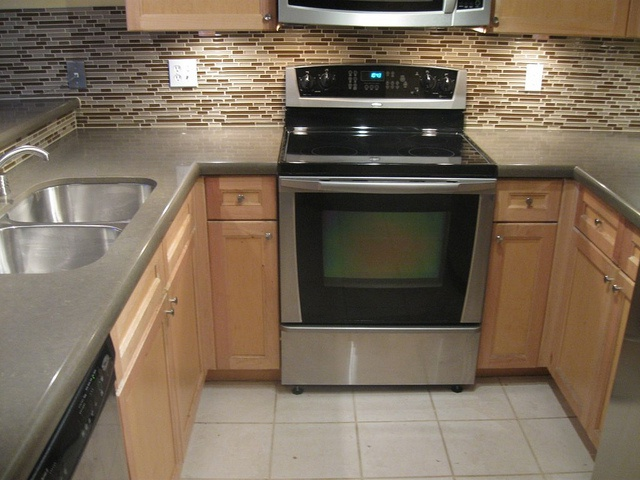Describe the objects in this image and their specific colors. I can see oven in gray and black tones, sink in gray, darkgray, and lightgray tones, and microwave in gray, black, white, and darkgray tones in this image. 